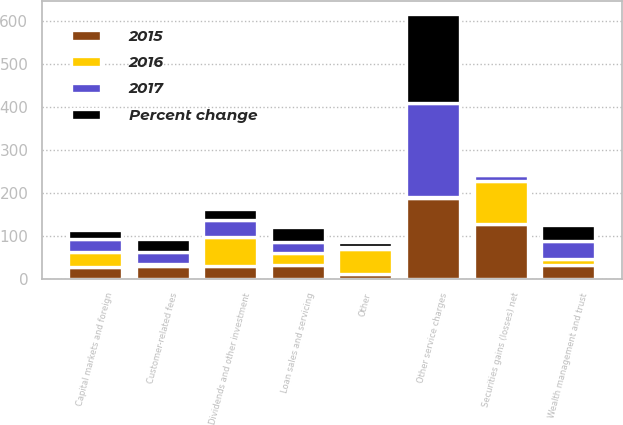<chart> <loc_0><loc_0><loc_500><loc_500><stacked_bar_chart><ecel><fcel>Other service charges<fcel>Wealth management and trust<fcel>Loan sales and servicing<fcel>Capital markets and foreign<fcel>Customer-related fees<fcel>Dividends and other investment<fcel>Securities gains (losses) net<fcel>Other<nl><fcel>2017<fcel>217<fcel>42<fcel>25<fcel>30<fcel>30<fcel>40<fcel>14<fcel>5<nl><fcel>2016<fcel>4<fcel>14<fcel>29<fcel>36<fcel>3<fcel>67<fcel>100<fcel>58<nl><fcel>Percent change<fcel>208<fcel>37<fcel>35<fcel>22<fcel>30<fcel>24<fcel>7<fcel>12<nl><fcel>2015<fcel>187<fcel>31<fcel>31<fcel>26<fcel>30<fcel>30<fcel>127<fcel>11<nl></chart> 